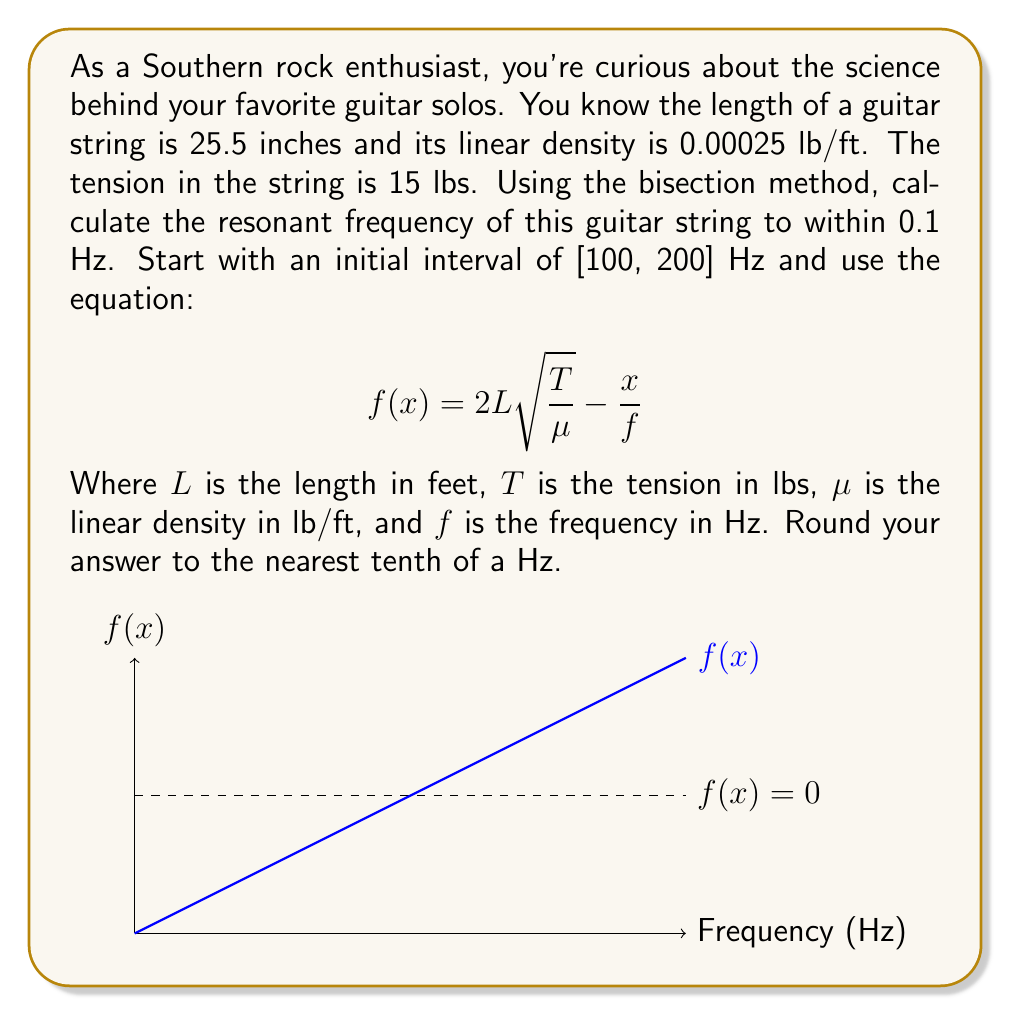Teach me how to tackle this problem. Let's approach this step-by-step using the bisection method:

1) First, convert the length to feet: 25.5 inches = 2.125 feet

2) Set up the function:
   $$f(x) = 2(2.125)\sqrt{\frac{15}{0.00025}} - \frac{x}{f}$$
   $$f(x) = 4.25\sqrt{60000} - \frac{x}{f} = 1039.23 - \frac{x}{f}$$

3) Initial interval: [a, b] = [100, 200]

4) Bisection method:

   Iteration 1:
   c = (a + b) / 2 = (100 + 200) / 2 = 150
   f(c) = 1039.23 - 150 = 889.23 > 0
   New interval: [100, 150]

   Iteration 2:
   c = (100 + 150) / 2 = 125
   f(c) = 1039.23 - 125 = 914.23 > 0
   New interval: [100, 125]

   Iteration 3:
   c = (100 + 125) / 2 = 112.5
   f(c) = 1039.23 - 112.5 = 926.73 > 0
   New interval: [100, 112.5]

   Iteration 4:
   c = (100 + 112.5) / 2 = 106.25
   f(c) = 1039.23 - 106.25 = 932.98 > 0
   New interval: [100, 106.25]

   Iteration 5:
   c = (100 + 106.25) / 2 = 103.125
   f(c) = 1039.23 - 103.125 = 936.105 > 0
   New interval: [100, 103.125]

   Iteration 6:
   c = (100 + 103.125) / 2 = 101.5625
   f(c) = 1039.23 - 101.5625 = 937.6675 > 0
   New interval: [100, 101.5625]

The difference between upper and lower bounds is now less than 0.1 Hz, so we can stop.

5) The resonant frequency is approximately 101.6 Hz (rounded to the nearest tenth).
Answer: 101.6 Hz 